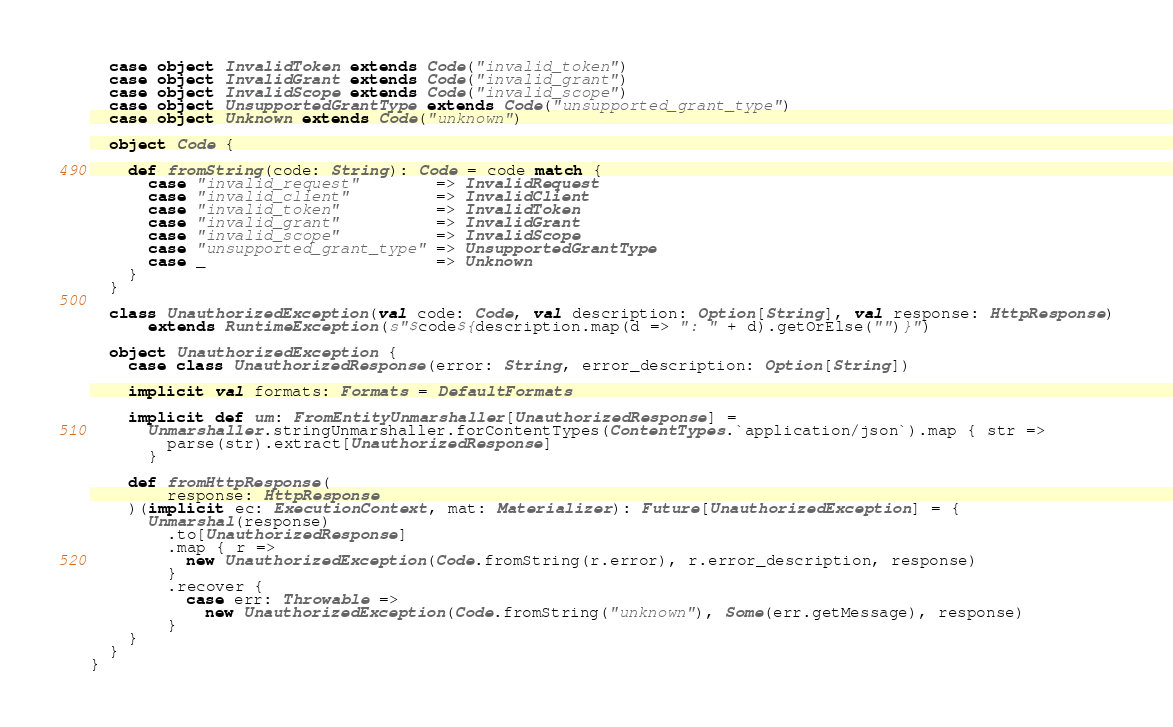Convert code to text. <code><loc_0><loc_0><loc_500><loc_500><_Scala_>  case object InvalidToken extends Code("invalid_token")
  case object InvalidGrant extends Code("invalid_grant")
  case object InvalidScope extends Code("invalid_scope")
  case object UnsupportedGrantType extends Code("unsupported_grant_type")
  case object Unknown extends Code("unknown")

  object Code {

    def fromString(code: String): Code = code match {
      case "invalid_request"        => InvalidRequest
      case "invalid_client"         => InvalidClient
      case "invalid_token"          => InvalidToken
      case "invalid_grant"          => InvalidGrant
      case "invalid_scope"          => InvalidScope
      case "unsupported_grant_type" => UnsupportedGrantType
      case _                        => Unknown
    }
  }

  class UnauthorizedException(val code: Code, val description: Option[String], val response: HttpResponse)
      extends RuntimeException(s"$code${description.map(d => ": " + d).getOrElse("")}")

  object UnauthorizedException {
    case class UnauthorizedResponse(error: String, error_description: Option[String])

    implicit val formats: Formats = DefaultFormats

    implicit def um: FromEntityUnmarshaller[UnauthorizedResponse] =
      Unmarshaller.stringUnmarshaller.forContentTypes(ContentTypes.`application/json`).map { str =>
        parse(str).extract[UnauthorizedResponse]
      }

    def fromHttpResponse(
        response: HttpResponse
    )(implicit ec: ExecutionContext, mat: Materializer): Future[UnauthorizedException] = {
      Unmarshal(response)
        .to[UnauthorizedResponse]
        .map { r =>
          new UnauthorizedException(Code.fromString(r.error), r.error_description, response)
        }
        .recover {
          case err: Throwable =>
            new UnauthorizedException(Code.fromString("unknown"), Some(err.getMessage), response)
        }
    }
  }
}
</code> 